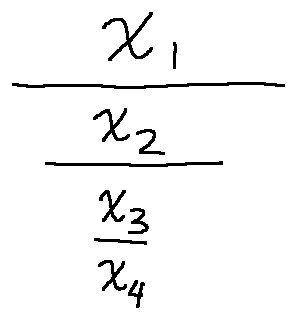<formula> <loc_0><loc_0><loc_500><loc_500>\frac { x _ { 1 } } { \frac { x _ { 2 } } { \frac { x _ { 3 } } { x _ { 4 } } } }</formula> 